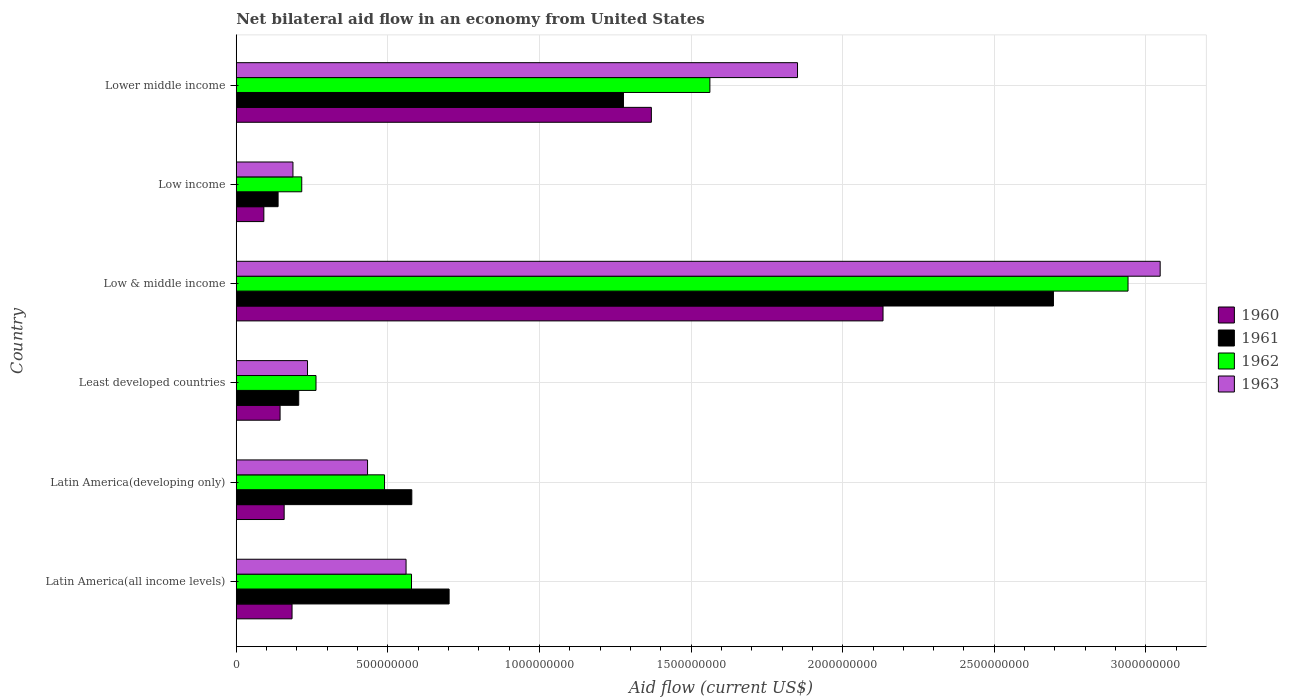How many different coloured bars are there?
Offer a very short reply. 4. Are the number of bars per tick equal to the number of legend labels?
Provide a short and direct response. Yes. Are the number of bars on each tick of the Y-axis equal?
Your answer should be very brief. Yes. How many bars are there on the 6th tick from the top?
Keep it short and to the point. 4. How many bars are there on the 3rd tick from the bottom?
Provide a short and direct response. 4. What is the label of the 2nd group of bars from the top?
Offer a terse response. Low income. In how many cases, is the number of bars for a given country not equal to the number of legend labels?
Your answer should be very brief. 0. What is the net bilateral aid flow in 1961 in Low & middle income?
Offer a very short reply. 2.70e+09. Across all countries, what is the maximum net bilateral aid flow in 1962?
Provide a succinct answer. 2.94e+09. Across all countries, what is the minimum net bilateral aid flow in 1961?
Provide a succinct answer. 1.38e+08. In which country was the net bilateral aid flow in 1961 maximum?
Keep it short and to the point. Low & middle income. In which country was the net bilateral aid flow in 1960 minimum?
Provide a short and direct response. Low income. What is the total net bilateral aid flow in 1963 in the graph?
Ensure brevity in your answer.  6.31e+09. What is the difference between the net bilateral aid flow in 1961 in Latin America(developing only) and that in Low income?
Your response must be concise. 4.41e+08. What is the difference between the net bilateral aid flow in 1962 in Latin America(all income levels) and the net bilateral aid flow in 1961 in Latin America(developing only)?
Your answer should be very brief. -1.00e+06. What is the average net bilateral aid flow in 1963 per country?
Your response must be concise. 1.05e+09. What is the difference between the net bilateral aid flow in 1962 and net bilateral aid flow in 1961 in Low income?
Your answer should be very brief. 7.80e+07. In how many countries, is the net bilateral aid flow in 1963 greater than 400000000 US$?
Keep it short and to the point. 4. What is the ratio of the net bilateral aid flow in 1962 in Latin America(developing only) to that in Low income?
Provide a succinct answer. 2.26. Is the net bilateral aid flow in 1962 in Latin America(all income levels) less than that in Low & middle income?
Make the answer very short. Yes. Is the difference between the net bilateral aid flow in 1962 in Latin America(all income levels) and Latin America(developing only) greater than the difference between the net bilateral aid flow in 1961 in Latin America(all income levels) and Latin America(developing only)?
Ensure brevity in your answer.  No. What is the difference between the highest and the second highest net bilateral aid flow in 1960?
Offer a very short reply. 7.64e+08. What is the difference between the highest and the lowest net bilateral aid flow in 1963?
Make the answer very short. 2.86e+09. What does the 2nd bar from the top in Low & middle income represents?
Give a very brief answer. 1962. What does the 1st bar from the bottom in Low & middle income represents?
Your answer should be very brief. 1960. Are all the bars in the graph horizontal?
Provide a short and direct response. Yes. How many countries are there in the graph?
Your answer should be compact. 6. Are the values on the major ticks of X-axis written in scientific E-notation?
Your answer should be compact. No. Does the graph contain grids?
Offer a terse response. Yes. How many legend labels are there?
Your answer should be very brief. 4. What is the title of the graph?
Offer a very short reply. Net bilateral aid flow in an economy from United States. Does "1969" appear as one of the legend labels in the graph?
Give a very brief answer. No. What is the Aid flow (current US$) in 1960 in Latin America(all income levels)?
Your answer should be compact. 1.84e+08. What is the Aid flow (current US$) of 1961 in Latin America(all income levels)?
Ensure brevity in your answer.  7.02e+08. What is the Aid flow (current US$) of 1962 in Latin America(all income levels)?
Offer a very short reply. 5.78e+08. What is the Aid flow (current US$) of 1963 in Latin America(all income levels)?
Offer a terse response. 5.60e+08. What is the Aid flow (current US$) in 1960 in Latin America(developing only)?
Your response must be concise. 1.58e+08. What is the Aid flow (current US$) in 1961 in Latin America(developing only)?
Provide a succinct answer. 5.79e+08. What is the Aid flow (current US$) of 1962 in Latin America(developing only)?
Offer a very short reply. 4.89e+08. What is the Aid flow (current US$) of 1963 in Latin America(developing only)?
Your answer should be compact. 4.33e+08. What is the Aid flow (current US$) of 1960 in Least developed countries?
Provide a short and direct response. 1.45e+08. What is the Aid flow (current US$) of 1961 in Least developed countries?
Your answer should be compact. 2.06e+08. What is the Aid flow (current US$) in 1962 in Least developed countries?
Your answer should be compact. 2.63e+08. What is the Aid flow (current US$) in 1963 in Least developed countries?
Offer a terse response. 2.35e+08. What is the Aid flow (current US$) in 1960 in Low & middle income?
Your answer should be very brief. 2.13e+09. What is the Aid flow (current US$) in 1961 in Low & middle income?
Offer a very short reply. 2.70e+09. What is the Aid flow (current US$) in 1962 in Low & middle income?
Your response must be concise. 2.94e+09. What is the Aid flow (current US$) of 1963 in Low & middle income?
Offer a terse response. 3.05e+09. What is the Aid flow (current US$) in 1960 in Low income?
Make the answer very short. 9.10e+07. What is the Aid flow (current US$) in 1961 in Low income?
Offer a very short reply. 1.38e+08. What is the Aid flow (current US$) of 1962 in Low income?
Your response must be concise. 2.16e+08. What is the Aid flow (current US$) of 1963 in Low income?
Provide a succinct answer. 1.87e+08. What is the Aid flow (current US$) in 1960 in Lower middle income?
Ensure brevity in your answer.  1.37e+09. What is the Aid flow (current US$) of 1961 in Lower middle income?
Your answer should be very brief. 1.28e+09. What is the Aid flow (current US$) of 1962 in Lower middle income?
Ensure brevity in your answer.  1.56e+09. What is the Aid flow (current US$) in 1963 in Lower middle income?
Your response must be concise. 1.85e+09. Across all countries, what is the maximum Aid flow (current US$) of 1960?
Offer a terse response. 2.13e+09. Across all countries, what is the maximum Aid flow (current US$) of 1961?
Provide a short and direct response. 2.70e+09. Across all countries, what is the maximum Aid flow (current US$) of 1962?
Keep it short and to the point. 2.94e+09. Across all countries, what is the maximum Aid flow (current US$) of 1963?
Keep it short and to the point. 3.05e+09. Across all countries, what is the minimum Aid flow (current US$) of 1960?
Keep it short and to the point. 9.10e+07. Across all countries, what is the minimum Aid flow (current US$) in 1961?
Your answer should be very brief. 1.38e+08. Across all countries, what is the minimum Aid flow (current US$) of 1962?
Your response must be concise. 2.16e+08. Across all countries, what is the minimum Aid flow (current US$) of 1963?
Your answer should be compact. 1.87e+08. What is the total Aid flow (current US$) in 1960 in the graph?
Offer a terse response. 4.08e+09. What is the total Aid flow (current US$) of 1961 in the graph?
Ensure brevity in your answer.  5.60e+09. What is the total Aid flow (current US$) in 1962 in the graph?
Your answer should be compact. 6.05e+09. What is the total Aid flow (current US$) in 1963 in the graph?
Keep it short and to the point. 6.31e+09. What is the difference between the Aid flow (current US$) of 1960 in Latin America(all income levels) and that in Latin America(developing only)?
Offer a terse response. 2.60e+07. What is the difference between the Aid flow (current US$) in 1961 in Latin America(all income levels) and that in Latin America(developing only)?
Give a very brief answer. 1.23e+08. What is the difference between the Aid flow (current US$) of 1962 in Latin America(all income levels) and that in Latin America(developing only)?
Your answer should be very brief. 8.90e+07. What is the difference between the Aid flow (current US$) of 1963 in Latin America(all income levels) and that in Latin America(developing only)?
Your answer should be very brief. 1.27e+08. What is the difference between the Aid flow (current US$) of 1960 in Latin America(all income levels) and that in Least developed countries?
Make the answer very short. 3.95e+07. What is the difference between the Aid flow (current US$) of 1961 in Latin America(all income levels) and that in Least developed countries?
Provide a succinct answer. 4.96e+08. What is the difference between the Aid flow (current US$) of 1962 in Latin America(all income levels) and that in Least developed countries?
Your response must be concise. 3.15e+08. What is the difference between the Aid flow (current US$) of 1963 in Latin America(all income levels) and that in Least developed countries?
Offer a very short reply. 3.25e+08. What is the difference between the Aid flow (current US$) in 1960 in Latin America(all income levels) and that in Low & middle income?
Provide a succinct answer. -1.95e+09. What is the difference between the Aid flow (current US$) of 1961 in Latin America(all income levels) and that in Low & middle income?
Your answer should be very brief. -1.99e+09. What is the difference between the Aid flow (current US$) of 1962 in Latin America(all income levels) and that in Low & middle income?
Provide a succinct answer. -2.36e+09. What is the difference between the Aid flow (current US$) in 1963 in Latin America(all income levels) and that in Low & middle income?
Provide a succinct answer. -2.49e+09. What is the difference between the Aid flow (current US$) of 1960 in Latin America(all income levels) and that in Low income?
Offer a terse response. 9.30e+07. What is the difference between the Aid flow (current US$) of 1961 in Latin America(all income levels) and that in Low income?
Offer a very short reply. 5.64e+08. What is the difference between the Aid flow (current US$) in 1962 in Latin America(all income levels) and that in Low income?
Give a very brief answer. 3.62e+08. What is the difference between the Aid flow (current US$) of 1963 in Latin America(all income levels) and that in Low income?
Offer a very short reply. 3.73e+08. What is the difference between the Aid flow (current US$) in 1960 in Latin America(all income levels) and that in Lower middle income?
Offer a very short reply. -1.18e+09. What is the difference between the Aid flow (current US$) in 1961 in Latin America(all income levels) and that in Lower middle income?
Your answer should be compact. -5.75e+08. What is the difference between the Aid flow (current US$) of 1962 in Latin America(all income levels) and that in Lower middle income?
Make the answer very short. -9.84e+08. What is the difference between the Aid flow (current US$) in 1963 in Latin America(all income levels) and that in Lower middle income?
Your answer should be very brief. -1.29e+09. What is the difference between the Aid flow (current US$) of 1960 in Latin America(developing only) and that in Least developed countries?
Provide a succinct answer. 1.35e+07. What is the difference between the Aid flow (current US$) in 1961 in Latin America(developing only) and that in Least developed countries?
Offer a terse response. 3.73e+08. What is the difference between the Aid flow (current US$) of 1962 in Latin America(developing only) and that in Least developed countries?
Your response must be concise. 2.26e+08. What is the difference between the Aid flow (current US$) in 1963 in Latin America(developing only) and that in Least developed countries?
Your answer should be compact. 1.98e+08. What is the difference between the Aid flow (current US$) in 1960 in Latin America(developing only) and that in Low & middle income?
Your answer should be compact. -1.98e+09. What is the difference between the Aid flow (current US$) in 1961 in Latin America(developing only) and that in Low & middle income?
Keep it short and to the point. -2.12e+09. What is the difference between the Aid flow (current US$) of 1962 in Latin America(developing only) and that in Low & middle income?
Your answer should be compact. -2.45e+09. What is the difference between the Aid flow (current US$) in 1963 in Latin America(developing only) and that in Low & middle income?
Offer a terse response. -2.61e+09. What is the difference between the Aid flow (current US$) of 1960 in Latin America(developing only) and that in Low income?
Ensure brevity in your answer.  6.70e+07. What is the difference between the Aid flow (current US$) in 1961 in Latin America(developing only) and that in Low income?
Keep it short and to the point. 4.41e+08. What is the difference between the Aid flow (current US$) of 1962 in Latin America(developing only) and that in Low income?
Your response must be concise. 2.73e+08. What is the difference between the Aid flow (current US$) in 1963 in Latin America(developing only) and that in Low income?
Your answer should be very brief. 2.46e+08. What is the difference between the Aid flow (current US$) in 1960 in Latin America(developing only) and that in Lower middle income?
Your answer should be compact. -1.21e+09. What is the difference between the Aid flow (current US$) in 1961 in Latin America(developing only) and that in Lower middle income?
Your answer should be compact. -6.98e+08. What is the difference between the Aid flow (current US$) in 1962 in Latin America(developing only) and that in Lower middle income?
Your answer should be compact. -1.07e+09. What is the difference between the Aid flow (current US$) of 1963 in Latin America(developing only) and that in Lower middle income?
Keep it short and to the point. -1.42e+09. What is the difference between the Aid flow (current US$) of 1960 in Least developed countries and that in Low & middle income?
Ensure brevity in your answer.  -1.99e+09. What is the difference between the Aid flow (current US$) in 1961 in Least developed countries and that in Low & middle income?
Offer a very short reply. -2.49e+09. What is the difference between the Aid flow (current US$) of 1962 in Least developed countries and that in Low & middle income?
Ensure brevity in your answer.  -2.68e+09. What is the difference between the Aid flow (current US$) of 1963 in Least developed countries and that in Low & middle income?
Give a very brief answer. -2.81e+09. What is the difference between the Aid flow (current US$) of 1960 in Least developed countries and that in Low income?
Give a very brief answer. 5.35e+07. What is the difference between the Aid flow (current US$) in 1961 in Least developed countries and that in Low income?
Your response must be concise. 6.80e+07. What is the difference between the Aid flow (current US$) of 1962 in Least developed countries and that in Low income?
Offer a very short reply. 4.70e+07. What is the difference between the Aid flow (current US$) in 1963 in Least developed countries and that in Low income?
Your response must be concise. 4.80e+07. What is the difference between the Aid flow (current US$) in 1960 in Least developed countries and that in Lower middle income?
Your response must be concise. -1.22e+09. What is the difference between the Aid flow (current US$) of 1961 in Least developed countries and that in Lower middle income?
Keep it short and to the point. -1.07e+09. What is the difference between the Aid flow (current US$) of 1962 in Least developed countries and that in Lower middle income?
Your answer should be very brief. -1.30e+09. What is the difference between the Aid flow (current US$) in 1963 in Least developed countries and that in Lower middle income?
Provide a succinct answer. -1.62e+09. What is the difference between the Aid flow (current US$) of 1960 in Low & middle income and that in Low income?
Your answer should be compact. 2.04e+09. What is the difference between the Aid flow (current US$) of 1961 in Low & middle income and that in Low income?
Offer a terse response. 2.56e+09. What is the difference between the Aid flow (current US$) of 1962 in Low & middle income and that in Low income?
Keep it short and to the point. 2.72e+09. What is the difference between the Aid flow (current US$) in 1963 in Low & middle income and that in Low income?
Keep it short and to the point. 2.86e+09. What is the difference between the Aid flow (current US$) of 1960 in Low & middle income and that in Lower middle income?
Offer a very short reply. 7.64e+08. What is the difference between the Aid flow (current US$) of 1961 in Low & middle income and that in Lower middle income?
Provide a succinct answer. 1.42e+09. What is the difference between the Aid flow (current US$) in 1962 in Low & middle income and that in Lower middle income?
Your answer should be very brief. 1.38e+09. What is the difference between the Aid flow (current US$) in 1963 in Low & middle income and that in Lower middle income?
Offer a terse response. 1.20e+09. What is the difference between the Aid flow (current US$) in 1960 in Low income and that in Lower middle income?
Keep it short and to the point. -1.28e+09. What is the difference between the Aid flow (current US$) in 1961 in Low income and that in Lower middle income?
Offer a very short reply. -1.14e+09. What is the difference between the Aid flow (current US$) in 1962 in Low income and that in Lower middle income?
Your response must be concise. -1.35e+09. What is the difference between the Aid flow (current US$) of 1963 in Low income and that in Lower middle income?
Offer a terse response. -1.66e+09. What is the difference between the Aid flow (current US$) of 1960 in Latin America(all income levels) and the Aid flow (current US$) of 1961 in Latin America(developing only)?
Offer a very short reply. -3.95e+08. What is the difference between the Aid flow (current US$) in 1960 in Latin America(all income levels) and the Aid flow (current US$) in 1962 in Latin America(developing only)?
Your response must be concise. -3.05e+08. What is the difference between the Aid flow (current US$) in 1960 in Latin America(all income levels) and the Aid flow (current US$) in 1963 in Latin America(developing only)?
Ensure brevity in your answer.  -2.49e+08. What is the difference between the Aid flow (current US$) of 1961 in Latin America(all income levels) and the Aid flow (current US$) of 1962 in Latin America(developing only)?
Give a very brief answer. 2.13e+08. What is the difference between the Aid flow (current US$) of 1961 in Latin America(all income levels) and the Aid flow (current US$) of 1963 in Latin America(developing only)?
Keep it short and to the point. 2.69e+08. What is the difference between the Aid flow (current US$) in 1962 in Latin America(all income levels) and the Aid flow (current US$) in 1963 in Latin America(developing only)?
Your response must be concise. 1.45e+08. What is the difference between the Aid flow (current US$) in 1960 in Latin America(all income levels) and the Aid flow (current US$) in 1961 in Least developed countries?
Your answer should be compact. -2.20e+07. What is the difference between the Aid flow (current US$) of 1960 in Latin America(all income levels) and the Aid flow (current US$) of 1962 in Least developed countries?
Your answer should be compact. -7.90e+07. What is the difference between the Aid flow (current US$) of 1960 in Latin America(all income levels) and the Aid flow (current US$) of 1963 in Least developed countries?
Your answer should be compact. -5.10e+07. What is the difference between the Aid flow (current US$) of 1961 in Latin America(all income levels) and the Aid flow (current US$) of 1962 in Least developed countries?
Keep it short and to the point. 4.39e+08. What is the difference between the Aid flow (current US$) in 1961 in Latin America(all income levels) and the Aid flow (current US$) in 1963 in Least developed countries?
Keep it short and to the point. 4.67e+08. What is the difference between the Aid flow (current US$) of 1962 in Latin America(all income levels) and the Aid flow (current US$) of 1963 in Least developed countries?
Ensure brevity in your answer.  3.43e+08. What is the difference between the Aid flow (current US$) in 1960 in Latin America(all income levels) and the Aid flow (current US$) in 1961 in Low & middle income?
Your response must be concise. -2.51e+09. What is the difference between the Aid flow (current US$) of 1960 in Latin America(all income levels) and the Aid flow (current US$) of 1962 in Low & middle income?
Your answer should be compact. -2.76e+09. What is the difference between the Aid flow (current US$) in 1960 in Latin America(all income levels) and the Aid flow (current US$) in 1963 in Low & middle income?
Your answer should be compact. -2.86e+09. What is the difference between the Aid flow (current US$) of 1961 in Latin America(all income levels) and the Aid flow (current US$) of 1962 in Low & middle income?
Offer a terse response. -2.24e+09. What is the difference between the Aid flow (current US$) in 1961 in Latin America(all income levels) and the Aid flow (current US$) in 1963 in Low & middle income?
Provide a short and direct response. -2.34e+09. What is the difference between the Aid flow (current US$) of 1962 in Latin America(all income levels) and the Aid flow (current US$) of 1963 in Low & middle income?
Offer a very short reply. -2.47e+09. What is the difference between the Aid flow (current US$) of 1960 in Latin America(all income levels) and the Aid flow (current US$) of 1961 in Low income?
Offer a very short reply. 4.60e+07. What is the difference between the Aid flow (current US$) of 1960 in Latin America(all income levels) and the Aid flow (current US$) of 1962 in Low income?
Make the answer very short. -3.20e+07. What is the difference between the Aid flow (current US$) in 1961 in Latin America(all income levels) and the Aid flow (current US$) in 1962 in Low income?
Provide a succinct answer. 4.86e+08. What is the difference between the Aid flow (current US$) in 1961 in Latin America(all income levels) and the Aid flow (current US$) in 1963 in Low income?
Make the answer very short. 5.15e+08. What is the difference between the Aid flow (current US$) in 1962 in Latin America(all income levels) and the Aid flow (current US$) in 1963 in Low income?
Your response must be concise. 3.91e+08. What is the difference between the Aid flow (current US$) of 1960 in Latin America(all income levels) and the Aid flow (current US$) of 1961 in Lower middle income?
Offer a very short reply. -1.09e+09. What is the difference between the Aid flow (current US$) of 1960 in Latin America(all income levels) and the Aid flow (current US$) of 1962 in Lower middle income?
Make the answer very short. -1.38e+09. What is the difference between the Aid flow (current US$) of 1960 in Latin America(all income levels) and the Aid flow (current US$) of 1963 in Lower middle income?
Ensure brevity in your answer.  -1.67e+09. What is the difference between the Aid flow (current US$) in 1961 in Latin America(all income levels) and the Aid flow (current US$) in 1962 in Lower middle income?
Make the answer very short. -8.60e+08. What is the difference between the Aid flow (current US$) in 1961 in Latin America(all income levels) and the Aid flow (current US$) in 1963 in Lower middle income?
Ensure brevity in your answer.  -1.15e+09. What is the difference between the Aid flow (current US$) in 1962 in Latin America(all income levels) and the Aid flow (current US$) in 1963 in Lower middle income?
Make the answer very short. -1.27e+09. What is the difference between the Aid flow (current US$) in 1960 in Latin America(developing only) and the Aid flow (current US$) in 1961 in Least developed countries?
Keep it short and to the point. -4.80e+07. What is the difference between the Aid flow (current US$) of 1960 in Latin America(developing only) and the Aid flow (current US$) of 1962 in Least developed countries?
Give a very brief answer. -1.05e+08. What is the difference between the Aid flow (current US$) of 1960 in Latin America(developing only) and the Aid flow (current US$) of 1963 in Least developed countries?
Offer a terse response. -7.70e+07. What is the difference between the Aid flow (current US$) of 1961 in Latin America(developing only) and the Aid flow (current US$) of 1962 in Least developed countries?
Give a very brief answer. 3.16e+08. What is the difference between the Aid flow (current US$) of 1961 in Latin America(developing only) and the Aid flow (current US$) of 1963 in Least developed countries?
Your answer should be very brief. 3.44e+08. What is the difference between the Aid flow (current US$) of 1962 in Latin America(developing only) and the Aid flow (current US$) of 1963 in Least developed countries?
Ensure brevity in your answer.  2.54e+08. What is the difference between the Aid flow (current US$) in 1960 in Latin America(developing only) and the Aid flow (current US$) in 1961 in Low & middle income?
Your answer should be very brief. -2.54e+09. What is the difference between the Aid flow (current US$) in 1960 in Latin America(developing only) and the Aid flow (current US$) in 1962 in Low & middle income?
Your answer should be very brief. -2.78e+09. What is the difference between the Aid flow (current US$) in 1960 in Latin America(developing only) and the Aid flow (current US$) in 1963 in Low & middle income?
Your response must be concise. -2.89e+09. What is the difference between the Aid flow (current US$) of 1961 in Latin America(developing only) and the Aid flow (current US$) of 1962 in Low & middle income?
Provide a short and direct response. -2.36e+09. What is the difference between the Aid flow (current US$) of 1961 in Latin America(developing only) and the Aid flow (current US$) of 1963 in Low & middle income?
Make the answer very short. -2.47e+09. What is the difference between the Aid flow (current US$) of 1962 in Latin America(developing only) and the Aid flow (current US$) of 1963 in Low & middle income?
Your response must be concise. -2.56e+09. What is the difference between the Aid flow (current US$) in 1960 in Latin America(developing only) and the Aid flow (current US$) in 1961 in Low income?
Keep it short and to the point. 2.00e+07. What is the difference between the Aid flow (current US$) of 1960 in Latin America(developing only) and the Aid flow (current US$) of 1962 in Low income?
Your answer should be very brief. -5.80e+07. What is the difference between the Aid flow (current US$) of 1960 in Latin America(developing only) and the Aid flow (current US$) of 1963 in Low income?
Offer a terse response. -2.90e+07. What is the difference between the Aid flow (current US$) in 1961 in Latin America(developing only) and the Aid flow (current US$) in 1962 in Low income?
Ensure brevity in your answer.  3.63e+08. What is the difference between the Aid flow (current US$) in 1961 in Latin America(developing only) and the Aid flow (current US$) in 1963 in Low income?
Keep it short and to the point. 3.92e+08. What is the difference between the Aid flow (current US$) in 1962 in Latin America(developing only) and the Aid flow (current US$) in 1963 in Low income?
Your answer should be very brief. 3.02e+08. What is the difference between the Aid flow (current US$) in 1960 in Latin America(developing only) and the Aid flow (current US$) in 1961 in Lower middle income?
Offer a very short reply. -1.12e+09. What is the difference between the Aid flow (current US$) in 1960 in Latin America(developing only) and the Aid flow (current US$) in 1962 in Lower middle income?
Keep it short and to the point. -1.40e+09. What is the difference between the Aid flow (current US$) of 1960 in Latin America(developing only) and the Aid flow (current US$) of 1963 in Lower middle income?
Your response must be concise. -1.69e+09. What is the difference between the Aid flow (current US$) of 1961 in Latin America(developing only) and the Aid flow (current US$) of 1962 in Lower middle income?
Give a very brief answer. -9.83e+08. What is the difference between the Aid flow (current US$) in 1961 in Latin America(developing only) and the Aid flow (current US$) in 1963 in Lower middle income?
Your answer should be very brief. -1.27e+09. What is the difference between the Aid flow (current US$) in 1962 in Latin America(developing only) and the Aid flow (current US$) in 1963 in Lower middle income?
Keep it short and to the point. -1.36e+09. What is the difference between the Aid flow (current US$) in 1960 in Least developed countries and the Aid flow (current US$) in 1961 in Low & middle income?
Your answer should be very brief. -2.55e+09. What is the difference between the Aid flow (current US$) in 1960 in Least developed countries and the Aid flow (current US$) in 1962 in Low & middle income?
Make the answer very short. -2.80e+09. What is the difference between the Aid flow (current US$) in 1960 in Least developed countries and the Aid flow (current US$) in 1963 in Low & middle income?
Provide a short and direct response. -2.90e+09. What is the difference between the Aid flow (current US$) in 1961 in Least developed countries and the Aid flow (current US$) in 1962 in Low & middle income?
Give a very brief answer. -2.74e+09. What is the difference between the Aid flow (current US$) in 1961 in Least developed countries and the Aid flow (current US$) in 1963 in Low & middle income?
Provide a short and direct response. -2.84e+09. What is the difference between the Aid flow (current US$) in 1962 in Least developed countries and the Aid flow (current US$) in 1963 in Low & middle income?
Offer a terse response. -2.78e+09. What is the difference between the Aid flow (current US$) in 1960 in Least developed countries and the Aid flow (current US$) in 1961 in Low income?
Give a very brief answer. 6.52e+06. What is the difference between the Aid flow (current US$) of 1960 in Least developed countries and the Aid flow (current US$) of 1962 in Low income?
Ensure brevity in your answer.  -7.15e+07. What is the difference between the Aid flow (current US$) in 1960 in Least developed countries and the Aid flow (current US$) in 1963 in Low income?
Provide a succinct answer. -4.25e+07. What is the difference between the Aid flow (current US$) of 1961 in Least developed countries and the Aid flow (current US$) of 1962 in Low income?
Make the answer very short. -1.00e+07. What is the difference between the Aid flow (current US$) in 1961 in Least developed countries and the Aid flow (current US$) in 1963 in Low income?
Make the answer very short. 1.90e+07. What is the difference between the Aid flow (current US$) in 1962 in Least developed countries and the Aid flow (current US$) in 1963 in Low income?
Make the answer very short. 7.60e+07. What is the difference between the Aid flow (current US$) of 1960 in Least developed countries and the Aid flow (current US$) of 1961 in Lower middle income?
Your answer should be compact. -1.13e+09. What is the difference between the Aid flow (current US$) in 1960 in Least developed countries and the Aid flow (current US$) in 1962 in Lower middle income?
Make the answer very short. -1.42e+09. What is the difference between the Aid flow (current US$) in 1960 in Least developed countries and the Aid flow (current US$) in 1963 in Lower middle income?
Make the answer very short. -1.71e+09. What is the difference between the Aid flow (current US$) of 1961 in Least developed countries and the Aid flow (current US$) of 1962 in Lower middle income?
Your answer should be very brief. -1.36e+09. What is the difference between the Aid flow (current US$) of 1961 in Least developed countries and the Aid flow (current US$) of 1963 in Lower middle income?
Ensure brevity in your answer.  -1.64e+09. What is the difference between the Aid flow (current US$) in 1962 in Least developed countries and the Aid flow (current US$) in 1963 in Lower middle income?
Make the answer very short. -1.59e+09. What is the difference between the Aid flow (current US$) in 1960 in Low & middle income and the Aid flow (current US$) in 1961 in Low income?
Keep it short and to the point. 2.00e+09. What is the difference between the Aid flow (current US$) of 1960 in Low & middle income and the Aid flow (current US$) of 1962 in Low income?
Provide a succinct answer. 1.92e+09. What is the difference between the Aid flow (current US$) of 1960 in Low & middle income and the Aid flow (current US$) of 1963 in Low income?
Your response must be concise. 1.95e+09. What is the difference between the Aid flow (current US$) of 1961 in Low & middle income and the Aid flow (current US$) of 1962 in Low income?
Make the answer very short. 2.48e+09. What is the difference between the Aid flow (current US$) in 1961 in Low & middle income and the Aid flow (current US$) in 1963 in Low income?
Your response must be concise. 2.51e+09. What is the difference between the Aid flow (current US$) of 1962 in Low & middle income and the Aid flow (current US$) of 1963 in Low income?
Provide a succinct answer. 2.75e+09. What is the difference between the Aid flow (current US$) of 1960 in Low & middle income and the Aid flow (current US$) of 1961 in Lower middle income?
Offer a terse response. 8.56e+08. What is the difference between the Aid flow (current US$) in 1960 in Low & middle income and the Aid flow (current US$) in 1962 in Lower middle income?
Offer a very short reply. 5.71e+08. What is the difference between the Aid flow (current US$) in 1960 in Low & middle income and the Aid flow (current US$) in 1963 in Lower middle income?
Your response must be concise. 2.82e+08. What is the difference between the Aid flow (current US$) of 1961 in Low & middle income and the Aid flow (current US$) of 1962 in Lower middle income?
Keep it short and to the point. 1.13e+09. What is the difference between the Aid flow (current US$) in 1961 in Low & middle income and the Aid flow (current US$) in 1963 in Lower middle income?
Give a very brief answer. 8.44e+08. What is the difference between the Aid flow (current US$) of 1962 in Low & middle income and the Aid flow (current US$) of 1963 in Lower middle income?
Your answer should be compact. 1.09e+09. What is the difference between the Aid flow (current US$) of 1960 in Low income and the Aid flow (current US$) of 1961 in Lower middle income?
Give a very brief answer. -1.19e+09. What is the difference between the Aid flow (current US$) in 1960 in Low income and the Aid flow (current US$) in 1962 in Lower middle income?
Ensure brevity in your answer.  -1.47e+09. What is the difference between the Aid flow (current US$) in 1960 in Low income and the Aid flow (current US$) in 1963 in Lower middle income?
Keep it short and to the point. -1.76e+09. What is the difference between the Aid flow (current US$) of 1961 in Low income and the Aid flow (current US$) of 1962 in Lower middle income?
Ensure brevity in your answer.  -1.42e+09. What is the difference between the Aid flow (current US$) of 1961 in Low income and the Aid flow (current US$) of 1963 in Lower middle income?
Your answer should be very brief. -1.71e+09. What is the difference between the Aid flow (current US$) in 1962 in Low income and the Aid flow (current US$) in 1963 in Lower middle income?
Ensure brevity in your answer.  -1.64e+09. What is the average Aid flow (current US$) in 1960 per country?
Give a very brief answer. 6.80e+08. What is the average Aid flow (current US$) of 1961 per country?
Keep it short and to the point. 9.33e+08. What is the average Aid flow (current US$) of 1962 per country?
Provide a succinct answer. 1.01e+09. What is the average Aid flow (current US$) in 1963 per country?
Your answer should be very brief. 1.05e+09. What is the difference between the Aid flow (current US$) of 1960 and Aid flow (current US$) of 1961 in Latin America(all income levels)?
Provide a succinct answer. -5.18e+08. What is the difference between the Aid flow (current US$) of 1960 and Aid flow (current US$) of 1962 in Latin America(all income levels)?
Offer a terse response. -3.94e+08. What is the difference between the Aid flow (current US$) in 1960 and Aid flow (current US$) in 1963 in Latin America(all income levels)?
Keep it short and to the point. -3.76e+08. What is the difference between the Aid flow (current US$) of 1961 and Aid flow (current US$) of 1962 in Latin America(all income levels)?
Provide a succinct answer. 1.24e+08. What is the difference between the Aid flow (current US$) in 1961 and Aid flow (current US$) in 1963 in Latin America(all income levels)?
Make the answer very short. 1.42e+08. What is the difference between the Aid flow (current US$) in 1962 and Aid flow (current US$) in 1963 in Latin America(all income levels)?
Your response must be concise. 1.80e+07. What is the difference between the Aid flow (current US$) of 1960 and Aid flow (current US$) of 1961 in Latin America(developing only)?
Offer a very short reply. -4.21e+08. What is the difference between the Aid flow (current US$) of 1960 and Aid flow (current US$) of 1962 in Latin America(developing only)?
Provide a succinct answer. -3.31e+08. What is the difference between the Aid flow (current US$) in 1960 and Aid flow (current US$) in 1963 in Latin America(developing only)?
Ensure brevity in your answer.  -2.75e+08. What is the difference between the Aid flow (current US$) in 1961 and Aid flow (current US$) in 1962 in Latin America(developing only)?
Offer a terse response. 9.00e+07. What is the difference between the Aid flow (current US$) in 1961 and Aid flow (current US$) in 1963 in Latin America(developing only)?
Offer a terse response. 1.46e+08. What is the difference between the Aid flow (current US$) of 1962 and Aid flow (current US$) of 1963 in Latin America(developing only)?
Offer a very short reply. 5.60e+07. What is the difference between the Aid flow (current US$) of 1960 and Aid flow (current US$) of 1961 in Least developed countries?
Provide a short and direct response. -6.15e+07. What is the difference between the Aid flow (current US$) of 1960 and Aid flow (current US$) of 1962 in Least developed countries?
Offer a terse response. -1.18e+08. What is the difference between the Aid flow (current US$) of 1960 and Aid flow (current US$) of 1963 in Least developed countries?
Offer a very short reply. -9.05e+07. What is the difference between the Aid flow (current US$) of 1961 and Aid flow (current US$) of 1962 in Least developed countries?
Offer a very short reply. -5.70e+07. What is the difference between the Aid flow (current US$) of 1961 and Aid flow (current US$) of 1963 in Least developed countries?
Your answer should be very brief. -2.90e+07. What is the difference between the Aid flow (current US$) of 1962 and Aid flow (current US$) of 1963 in Least developed countries?
Your response must be concise. 2.80e+07. What is the difference between the Aid flow (current US$) of 1960 and Aid flow (current US$) of 1961 in Low & middle income?
Ensure brevity in your answer.  -5.62e+08. What is the difference between the Aid flow (current US$) in 1960 and Aid flow (current US$) in 1962 in Low & middle income?
Provide a short and direct response. -8.08e+08. What is the difference between the Aid flow (current US$) of 1960 and Aid flow (current US$) of 1963 in Low & middle income?
Offer a terse response. -9.14e+08. What is the difference between the Aid flow (current US$) of 1961 and Aid flow (current US$) of 1962 in Low & middle income?
Offer a very short reply. -2.46e+08. What is the difference between the Aid flow (current US$) of 1961 and Aid flow (current US$) of 1963 in Low & middle income?
Keep it short and to the point. -3.52e+08. What is the difference between the Aid flow (current US$) of 1962 and Aid flow (current US$) of 1963 in Low & middle income?
Make the answer very short. -1.06e+08. What is the difference between the Aid flow (current US$) in 1960 and Aid flow (current US$) in 1961 in Low income?
Your response must be concise. -4.70e+07. What is the difference between the Aid flow (current US$) in 1960 and Aid flow (current US$) in 1962 in Low income?
Provide a succinct answer. -1.25e+08. What is the difference between the Aid flow (current US$) in 1960 and Aid flow (current US$) in 1963 in Low income?
Offer a terse response. -9.60e+07. What is the difference between the Aid flow (current US$) in 1961 and Aid flow (current US$) in 1962 in Low income?
Ensure brevity in your answer.  -7.80e+07. What is the difference between the Aid flow (current US$) in 1961 and Aid flow (current US$) in 1963 in Low income?
Provide a short and direct response. -4.90e+07. What is the difference between the Aid flow (current US$) in 1962 and Aid flow (current US$) in 1963 in Low income?
Offer a very short reply. 2.90e+07. What is the difference between the Aid flow (current US$) in 1960 and Aid flow (current US$) in 1961 in Lower middle income?
Give a very brief answer. 9.20e+07. What is the difference between the Aid flow (current US$) in 1960 and Aid flow (current US$) in 1962 in Lower middle income?
Your answer should be compact. -1.93e+08. What is the difference between the Aid flow (current US$) in 1960 and Aid flow (current US$) in 1963 in Lower middle income?
Your response must be concise. -4.82e+08. What is the difference between the Aid flow (current US$) in 1961 and Aid flow (current US$) in 1962 in Lower middle income?
Make the answer very short. -2.85e+08. What is the difference between the Aid flow (current US$) in 1961 and Aid flow (current US$) in 1963 in Lower middle income?
Your answer should be very brief. -5.74e+08. What is the difference between the Aid flow (current US$) in 1962 and Aid flow (current US$) in 1963 in Lower middle income?
Make the answer very short. -2.89e+08. What is the ratio of the Aid flow (current US$) in 1960 in Latin America(all income levels) to that in Latin America(developing only)?
Your answer should be compact. 1.16. What is the ratio of the Aid flow (current US$) of 1961 in Latin America(all income levels) to that in Latin America(developing only)?
Your answer should be very brief. 1.21. What is the ratio of the Aid flow (current US$) of 1962 in Latin America(all income levels) to that in Latin America(developing only)?
Ensure brevity in your answer.  1.18. What is the ratio of the Aid flow (current US$) of 1963 in Latin America(all income levels) to that in Latin America(developing only)?
Provide a short and direct response. 1.29. What is the ratio of the Aid flow (current US$) in 1960 in Latin America(all income levels) to that in Least developed countries?
Your response must be concise. 1.27. What is the ratio of the Aid flow (current US$) in 1961 in Latin America(all income levels) to that in Least developed countries?
Offer a terse response. 3.41. What is the ratio of the Aid flow (current US$) of 1962 in Latin America(all income levels) to that in Least developed countries?
Ensure brevity in your answer.  2.2. What is the ratio of the Aid flow (current US$) in 1963 in Latin America(all income levels) to that in Least developed countries?
Your answer should be compact. 2.38. What is the ratio of the Aid flow (current US$) in 1960 in Latin America(all income levels) to that in Low & middle income?
Provide a succinct answer. 0.09. What is the ratio of the Aid flow (current US$) of 1961 in Latin America(all income levels) to that in Low & middle income?
Offer a very short reply. 0.26. What is the ratio of the Aid flow (current US$) in 1962 in Latin America(all income levels) to that in Low & middle income?
Your answer should be compact. 0.2. What is the ratio of the Aid flow (current US$) of 1963 in Latin America(all income levels) to that in Low & middle income?
Give a very brief answer. 0.18. What is the ratio of the Aid flow (current US$) of 1960 in Latin America(all income levels) to that in Low income?
Ensure brevity in your answer.  2.02. What is the ratio of the Aid flow (current US$) in 1961 in Latin America(all income levels) to that in Low income?
Offer a very short reply. 5.09. What is the ratio of the Aid flow (current US$) of 1962 in Latin America(all income levels) to that in Low income?
Give a very brief answer. 2.68. What is the ratio of the Aid flow (current US$) in 1963 in Latin America(all income levels) to that in Low income?
Give a very brief answer. 2.99. What is the ratio of the Aid flow (current US$) of 1960 in Latin America(all income levels) to that in Lower middle income?
Provide a short and direct response. 0.13. What is the ratio of the Aid flow (current US$) in 1961 in Latin America(all income levels) to that in Lower middle income?
Offer a terse response. 0.55. What is the ratio of the Aid flow (current US$) in 1962 in Latin America(all income levels) to that in Lower middle income?
Offer a very short reply. 0.37. What is the ratio of the Aid flow (current US$) of 1963 in Latin America(all income levels) to that in Lower middle income?
Ensure brevity in your answer.  0.3. What is the ratio of the Aid flow (current US$) of 1960 in Latin America(developing only) to that in Least developed countries?
Offer a terse response. 1.09. What is the ratio of the Aid flow (current US$) in 1961 in Latin America(developing only) to that in Least developed countries?
Make the answer very short. 2.81. What is the ratio of the Aid flow (current US$) of 1962 in Latin America(developing only) to that in Least developed countries?
Make the answer very short. 1.86. What is the ratio of the Aid flow (current US$) in 1963 in Latin America(developing only) to that in Least developed countries?
Offer a terse response. 1.84. What is the ratio of the Aid flow (current US$) in 1960 in Latin America(developing only) to that in Low & middle income?
Give a very brief answer. 0.07. What is the ratio of the Aid flow (current US$) of 1961 in Latin America(developing only) to that in Low & middle income?
Your answer should be very brief. 0.21. What is the ratio of the Aid flow (current US$) of 1962 in Latin America(developing only) to that in Low & middle income?
Offer a terse response. 0.17. What is the ratio of the Aid flow (current US$) in 1963 in Latin America(developing only) to that in Low & middle income?
Offer a very short reply. 0.14. What is the ratio of the Aid flow (current US$) of 1960 in Latin America(developing only) to that in Low income?
Your response must be concise. 1.74. What is the ratio of the Aid flow (current US$) of 1961 in Latin America(developing only) to that in Low income?
Offer a very short reply. 4.2. What is the ratio of the Aid flow (current US$) of 1962 in Latin America(developing only) to that in Low income?
Offer a very short reply. 2.26. What is the ratio of the Aid flow (current US$) of 1963 in Latin America(developing only) to that in Low income?
Provide a succinct answer. 2.32. What is the ratio of the Aid flow (current US$) of 1960 in Latin America(developing only) to that in Lower middle income?
Keep it short and to the point. 0.12. What is the ratio of the Aid flow (current US$) of 1961 in Latin America(developing only) to that in Lower middle income?
Your answer should be very brief. 0.45. What is the ratio of the Aid flow (current US$) of 1962 in Latin America(developing only) to that in Lower middle income?
Provide a succinct answer. 0.31. What is the ratio of the Aid flow (current US$) in 1963 in Latin America(developing only) to that in Lower middle income?
Your response must be concise. 0.23. What is the ratio of the Aid flow (current US$) of 1960 in Least developed countries to that in Low & middle income?
Give a very brief answer. 0.07. What is the ratio of the Aid flow (current US$) in 1961 in Least developed countries to that in Low & middle income?
Give a very brief answer. 0.08. What is the ratio of the Aid flow (current US$) of 1962 in Least developed countries to that in Low & middle income?
Your response must be concise. 0.09. What is the ratio of the Aid flow (current US$) in 1963 in Least developed countries to that in Low & middle income?
Provide a succinct answer. 0.08. What is the ratio of the Aid flow (current US$) in 1960 in Least developed countries to that in Low income?
Provide a succinct answer. 1.59. What is the ratio of the Aid flow (current US$) of 1961 in Least developed countries to that in Low income?
Provide a short and direct response. 1.49. What is the ratio of the Aid flow (current US$) of 1962 in Least developed countries to that in Low income?
Keep it short and to the point. 1.22. What is the ratio of the Aid flow (current US$) of 1963 in Least developed countries to that in Low income?
Provide a succinct answer. 1.26. What is the ratio of the Aid flow (current US$) in 1960 in Least developed countries to that in Lower middle income?
Give a very brief answer. 0.11. What is the ratio of the Aid flow (current US$) of 1961 in Least developed countries to that in Lower middle income?
Keep it short and to the point. 0.16. What is the ratio of the Aid flow (current US$) in 1962 in Least developed countries to that in Lower middle income?
Provide a short and direct response. 0.17. What is the ratio of the Aid flow (current US$) in 1963 in Least developed countries to that in Lower middle income?
Give a very brief answer. 0.13. What is the ratio of the Aid flow (current US$) in 1960 in Low & middle income to that in Low income?
Keep it short and to the point. 23.44. What is the ratio of the Aid flow (current US$) of 1961 in Low & middle income to that in Low income?
Your answer should be very brief. 19.53. What is the ratio of the Aid flow (current US$) of 1962 in Low & middle income to that in Low income?
Give a very brief answer. 13.62. What is the ratio of the Aid flow (current US$) in 1963 in Low & middle income to that in Low income?
Offer a very short reply. 16.29. What is the ratio of the Aid flow (current US$) of 1960 in Low & middle income to that in Lower middle income?
Provide a succinct answer. 1.56. What is the ratio of the Aid flow (current US$) of 1961 in Low & middle income to that in Lower middle income?
Keep it short and to the point. 2.11. What is the ratio of the Aid flow (current US$) of 1962 in Low & middle income to that in Lower middle income?
Ensure brevity in your answer.  1.88. What is the ratio of the Aid flow (current US$) in 1963 in Low & middle income to that in Lower middle income?
Give a very brief answer. 1.65. What is the ratio of the Aid flow (current US$) of 1960 in Low income to that in Lower middle income?
Your response must be concise. 0.07. What is the ratio of the Aid flow (current US$) in 1961 in Low income to that in Lower middle income?
Offer a very short reply. 0.11. What is the ratio of the Aid flow (current US$) in 1962 in Low income to that in Lower middle income?
Ensure brevity in your answer.  0.14. What is the ratio of the Aid flow (current US$) of 1963 in Low income to that in Lower middle income?
Your answer should be compact. 0.1. What is the difference between the highest and the second highest Aid flow (current US$) of 1960?
Your answer should be very brief. 7.64e+08. What is the difference between the highest and the second highest Aid flow (current US$) of 1961?
Your response must be concise. 1.42e+09. What is the difference between the highest and the second highest Aid flow (current US$) of 1962?
Your answer should be compact. 1.38e+09. What is the difference between the highest and the second highest Aid flow (current US$) in 1963?
Your answer should be very brief. 1.20e+09. What is the difference between the highest and the lowest Aid flow (current US$) in 1960?
Keep it short and to the point. 2.04e+09. What is the difference between the highest and the lowest Aid flow (current US$) in 1961?
Your response must be concise. 2.56e+09. What is the difference between the highest and the lowest Aid flow (current US$) in 1962?
Ensure brevity in your answer.  2.72e+09. What is the difference between the highest and the lowest Aid flow (current US$) in 1963?
Offer a very short reply. 2.86e+09. 